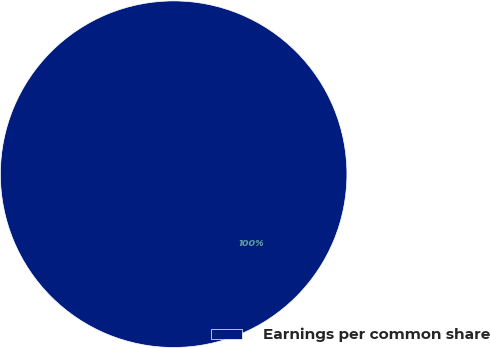Convert chart. <chart><loc_0><loc_0><loc_500><loc_500><pie_chart><fcel>Earnings per common share<nl><fcel>100.0%<nl></chart> 